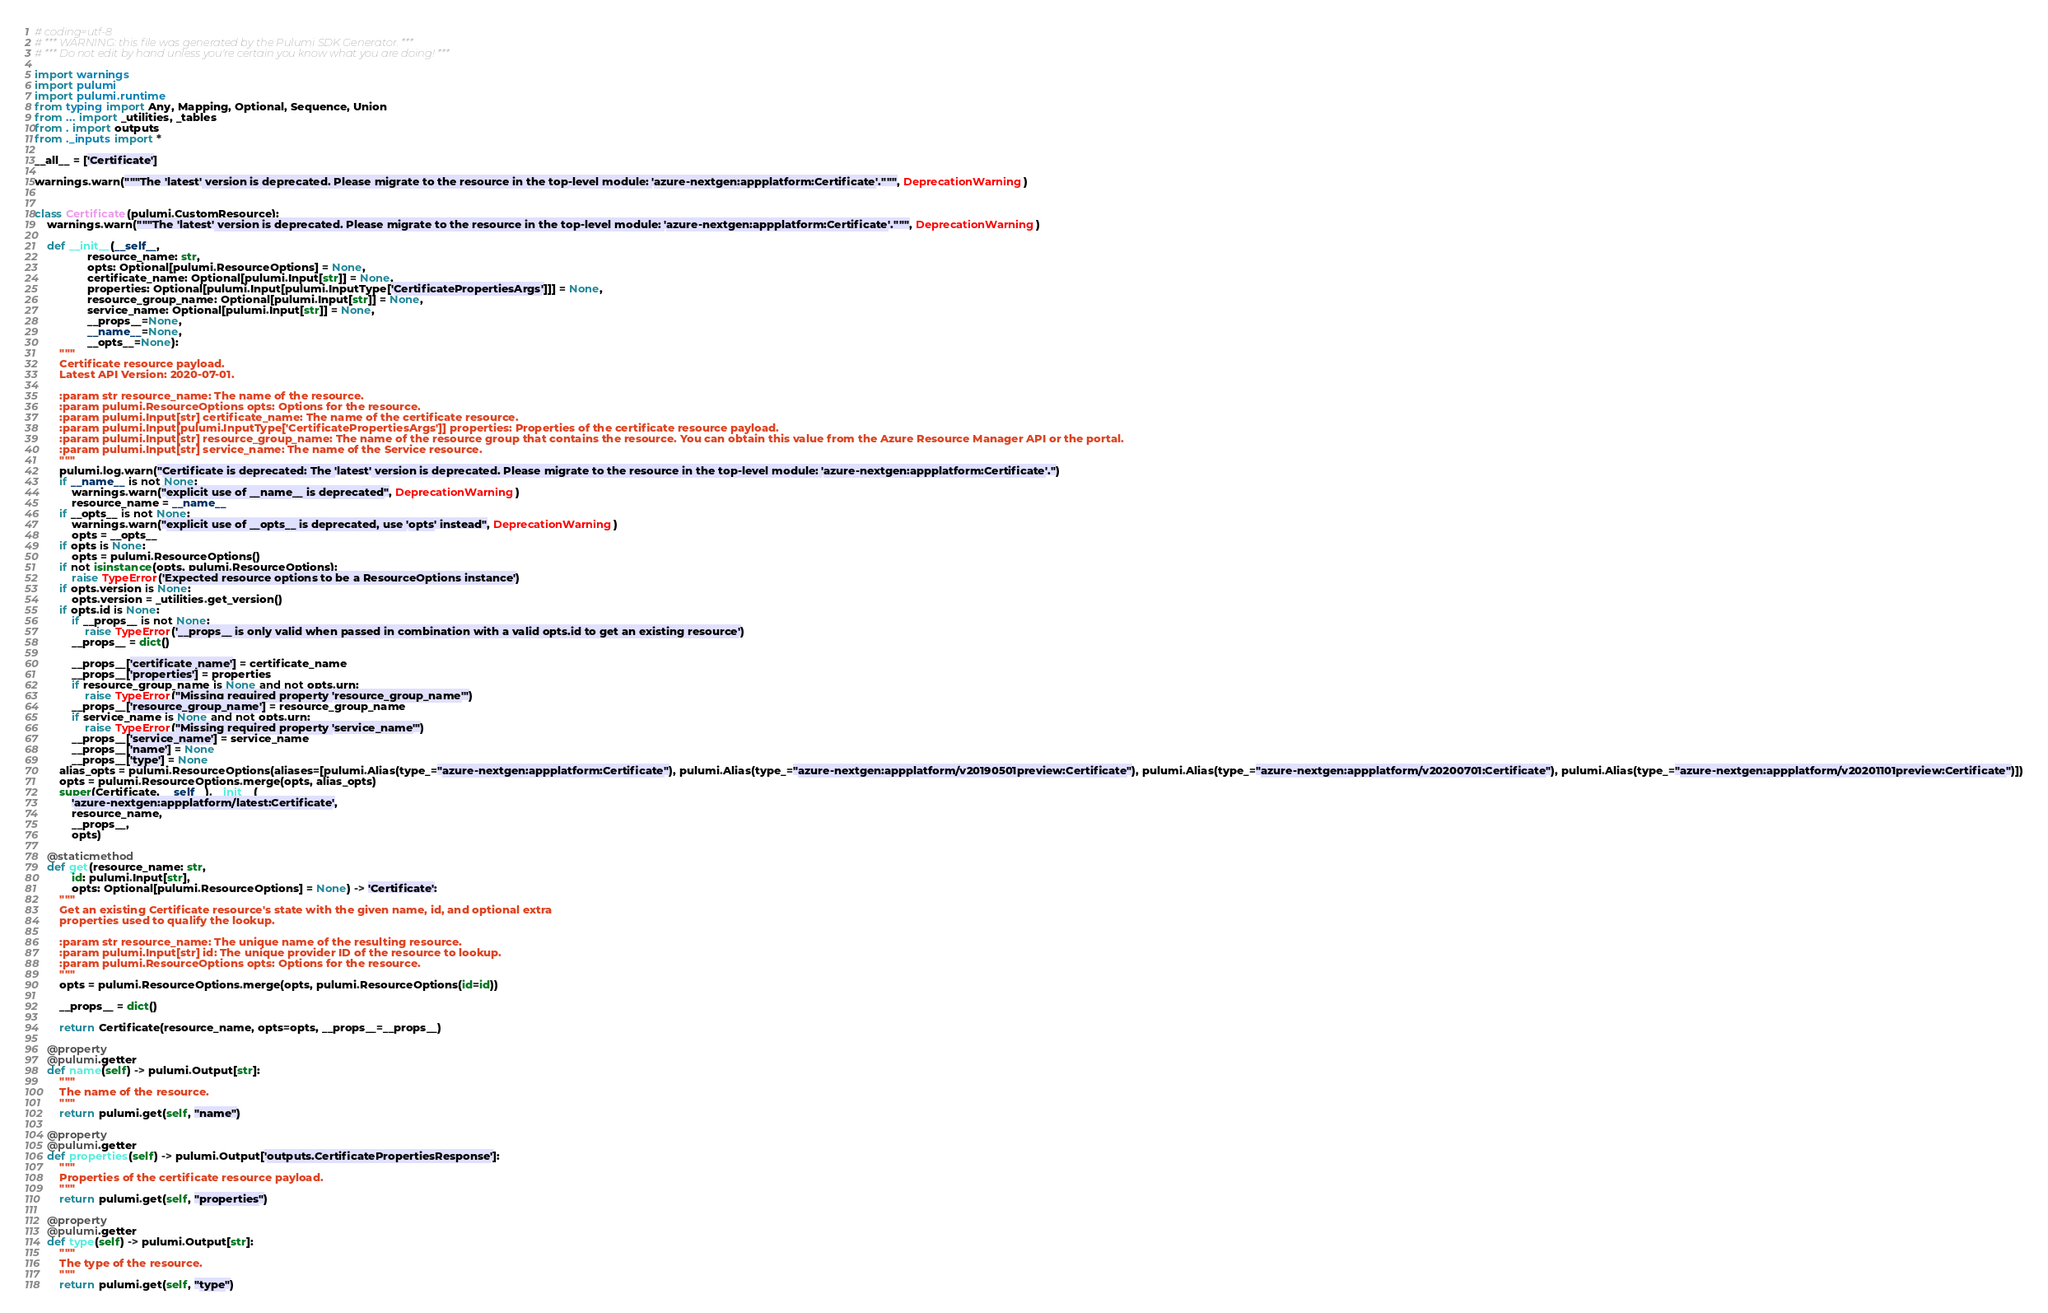Convert code to text. <code><loc_0><loc_0><loc_500><loc_500><_Python_># coding=utf-8
# *** WARNING: this file was generated by the Pulumi SDK Generator. ***
# *** Do not edit by hand unless you're certain you know what you are doing! ***

import warnings
import pulumi
import pulumi.runtime
from typing import Any, Mapping, Optional, Sequence, Union
from ... import _utilities, _tables
from . import outputs
from ._inputs import *

__all__ = ['Certificate']

warnings.warn("""The 'latest' version is deprecated. Please migrate to the resource in the top-level module: 'azure-nextgen:appplatform:Certificate'.""", DeprecationWarning)


class Certificate(pulumi.CustomResource):
    warnings.warn("""The 'latest' version is deprecated. Please migrate to the resource in the top-level module: 'azure-nextgen:appplatform:Certificate'.""", DeprecationWarning)

    def __init__(__self__,
                 resource_name: str,
                 opts: Optional[pulumi.ResourceOptions] = None,
                 certificate_name: Optional[pulumi.Input[str]] = None,
                 properties: Optional[pulumi.Input[pulumi.InputType['CertificatePropertiesArgs']]] = None,
                 resource_group_name: Optional[pulumi.Input[str]] = None,
                 service_name: Optional[pulumi.Input[str]] = None,
                 __props__=None,
                 __name__=None,
                 __opts__=None):
        """
        Certificate resource payload.
        Latest API Version: 2020-07-01.

        :param str resource_name: The name of the resource.
        :param pulumi.ResourceOptions opts: Options for the resource.
        :param pulumi.Input[str] certificate_name: The name of the certificate resource.
        :param pulumi.Input[pulumi.InputType['CertificatePropertiesArgs']] properties: Properties of the certificate resource payload.
        :param pulumi.Input[str] resource_group_name: The name of the resource group that contains the resource. You can obtain this value from the Azure Resource Manager API or the portal.
        :param pulumi.Input[str] service_name: The name of the Service resource.
        """
        pulumi.log.warn("Certificate is deprecated: The 'latest' version is deprecated. Please migrate to the resource in the top-level module: 'azure-nextgen:appplatform:Certificate'.")
        if __name__ is not None:
            warnings.warn("explicit use of __name__ is deprecated", DeprecationWarning)
            resource_name = __name__
        if __opts__ is not None:
            warnings.warn("explicit use of __opts__ is deprecated, use 'opts' instead", DeprecationWarning)
            opts = __opts__
        if opts is None:
            opts = pulumi.ResourceOptions()
        if not isinstance(opts, pulumi.ResourceOptions):
            raise TypeError('Expected resource options to be a ResourceOptions instance')
        if opts.version is None:
            opts.version = _utilities.get_version()
        if opts.id is None:
            if __props__ is not None:
                raise TypeError('__props__ is only valid when passed in combination with a valid opts.id to get an existing resource')
            __props__ = dict()

            __props__['certificate_name'] = certificate_name
            __props__['properties'] = properties
            if resource_group_name is None and not opts.urn:
                raise TypeError("Missing required property 'resource_group_name'")
            __props__['resource_group_name'] = resource_group_name
            if service_name is None and not opts.urn:
                raise TypeError("Missing required property 'service_name'")
            __props__['service_name'] = service_name
            __props__['name'] = None
            __props__['type'] = None
        alias_opts = pulumi.ResourceOptions(aliases=[pulumi.Alias(type_="azure-nextgen:appplatform:Certificate"), pulumi.Alias(type_="azure-nextgen:appplatform/v20190501preview:Certificate"), pulumi.Alias(type_="azure-nextgen:appplatform/v20200701:Certificate"), pulumi.Alias(type_="azure-nextgen:appplatform/v20201101preview:Certificate")])
        opts = pulumi.ResourceOptions.merge(opts, alias_opts)
        super(Certificate, __self__).__init__(
            'azure-nextgen:appplatform/latest:Certificate',
            resource_name,
            __props__,
            opts)

    @staticmethod
    def get(resource_name: str,
            id: pulumi.Input[str],
            opts: Optional[pulumi.ResourceOptions] = None) -> 'Certificate':
        """
        Get an existing Certificate resource's state with the given name, id, and optional extra
        properties used to qualify the lookup.

        :param str resource_name: The unique name of the resulting resource.
        :param pulumi.Input[str] id: The unique provider ID of the resource to lookup.
        :param pulumi.ResourceOptions opts: Options for the resource.
        """
        opts = pulumi.ResourceOptions.merge(opts, pulumi.ResourceOptions(id=id))

        __props__ = dict()

        return Certificate(resource_name, opts=opts, __props__=__props__)

    @property
    @pulumi.getter
    def name(self) -> pulumi.Output[str]:
        """
        The name of the resource.
        """
        return pulumi.get(self, "name")

    @property
    @pulumi.getter
    def properties(self) -> pulumi.Output['outputs.CertificatePropertiesResponse']:
        """
        Properties of the certificate resource payload.
        """
        return pulumi.get(self, "properties")

    @property
    @pulumi.getter
    def type(self) -> pulumi.Output[str]:
        """
        The type of the resource.
        """
        return pulumi.get(self, "type")
</code> 